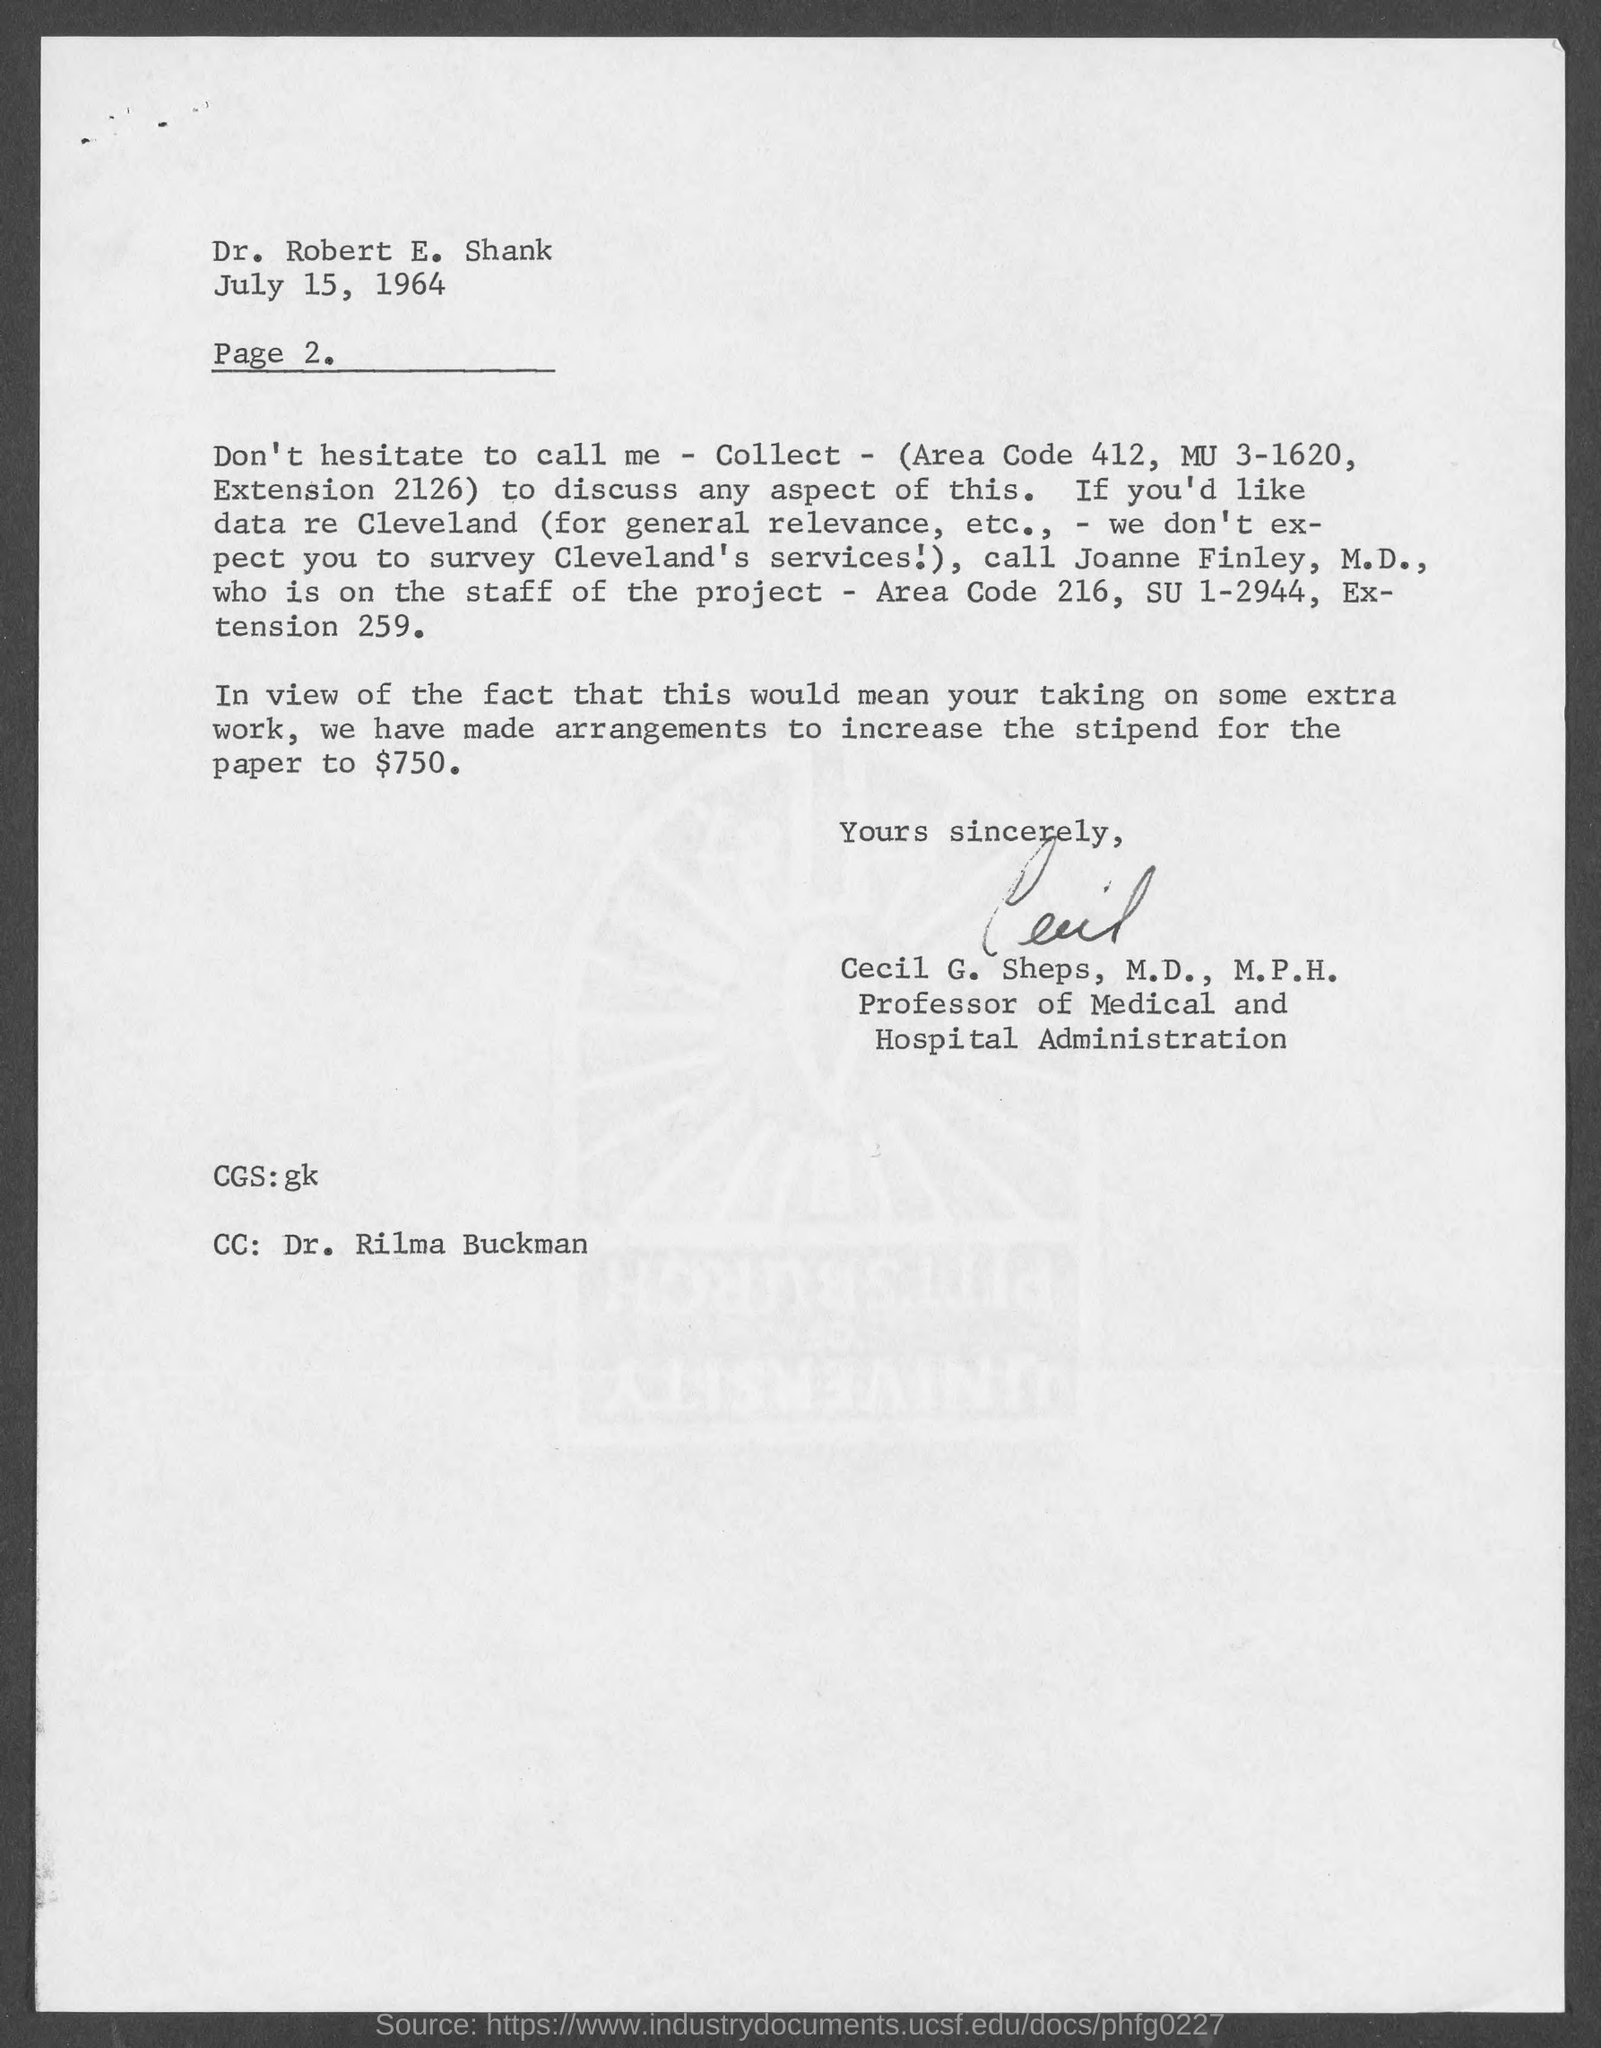Outline some significant characteristics in this image. The stipend for a paper that has been arranged to increase will now be $750. The page number mentioned below the date is 2. Dr. Rilma Buckman is mentioned at the bottom-left of the page, and CC is mentioned. Cecil G. Sheps, M.D., M.P.H., is the professor of Medical and Hospital Administration. The letter is dated on July 15, 1964. 